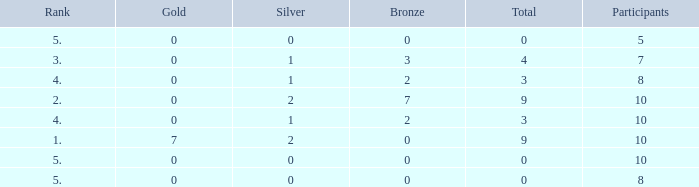What is listed as the highest Gold that also has a Silver that's smaller than 1, and has a Total that's smaller than 0? None. 